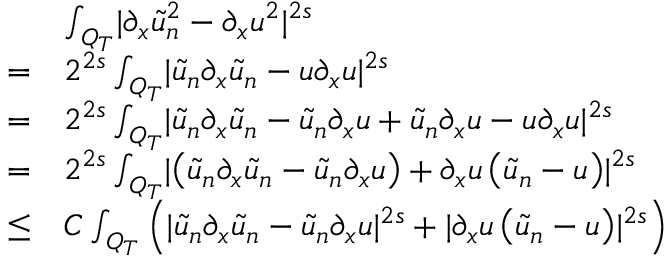Convert formula to latex. <formula><loc_0><loc_0><loc_500><loc_500>\begin{array} { r l } & { \int _ { Q _ { T } } | \partial _ { x } \tilde { u } _ { n } ^ { 2 } - \partial _ { x } u ^ { 2 } | ^ { 2 s } } \\ { = } & { 2 ^ { 2 s } \int _ { Q _ { T } } | \tilde { u } _ { n } \partial _ { x } \tilde { u } _ { n } - u \partial _ { x } u | ^ { 2 s } } \\ { = } & { 2 ^ { 2 s } \int _ { Q _ { T } } | \tilde { u } _ { n } \partial _ { x } \tilde { u } _ { n } - \tilde { u } _ { n } \partial _ { x } u + \tilde { u } _ { n } \partial _ { x } u - u \partial _ { x } u | ^ { 2 s } } \\ { = } & { 2 ^ { 2 s } \int _ { Q _ { T } } | \left ( \tilde { u } _ { n } \partial _ { x } \tilde { u } _ { n } - \tilde { u } _ { n } \partial _ { x } u \right ) + \partial _ { x } u \left ( \tilde { u } _ { n } - u \right ) | ^ { 2 s } } \\ { \leq } & { C \int _ { Q _ { T } } \left ( | \tilde { u } _ { n } \partial _ { x } \tilde { u } _ { n } - \tilde { u } _ { n } \partial _ { x } u | ^ { 2 s } + | \partial _ { x } u \left ( \tilde { u } _ { n } - u \right ) | ^ { 2 s } \right ) } \end{array}</formula> 